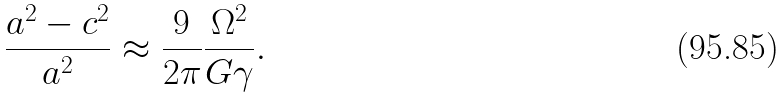<formula> <loc_0><loc_0><loc_500><loc_500>\frac { a ^ { 2 } - c ^ { 2 } } { a ^ { 2 } } \approx \frac { 9 } { 2 \pi } \frac { \Omega ^ { 2 } } { G \gamma } .</formula> 